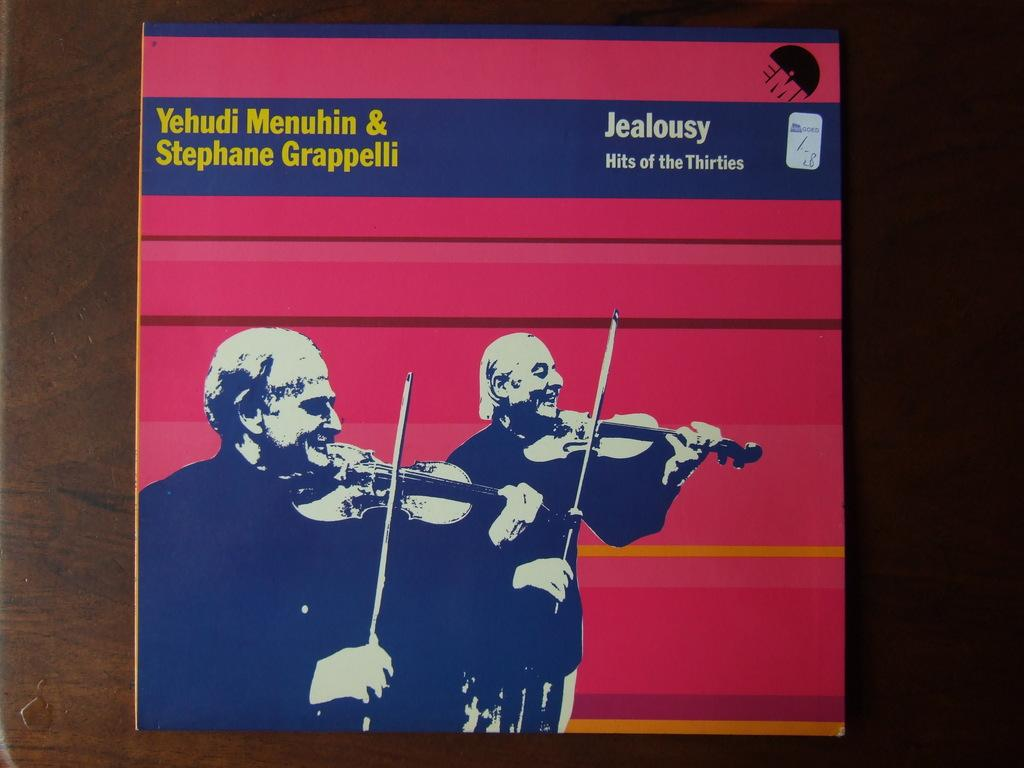<image>
Provide a brief description of the given image. A record album that features songs from the 1930s. 